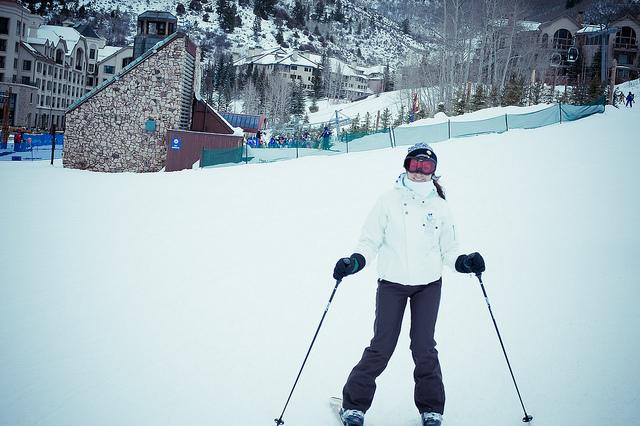What is the weather like?
Keep it brief. Cold. What sport is this?
Write a very short answer. Skiing. What color is the goggles she is wearing?
Concise answer only. Red. 